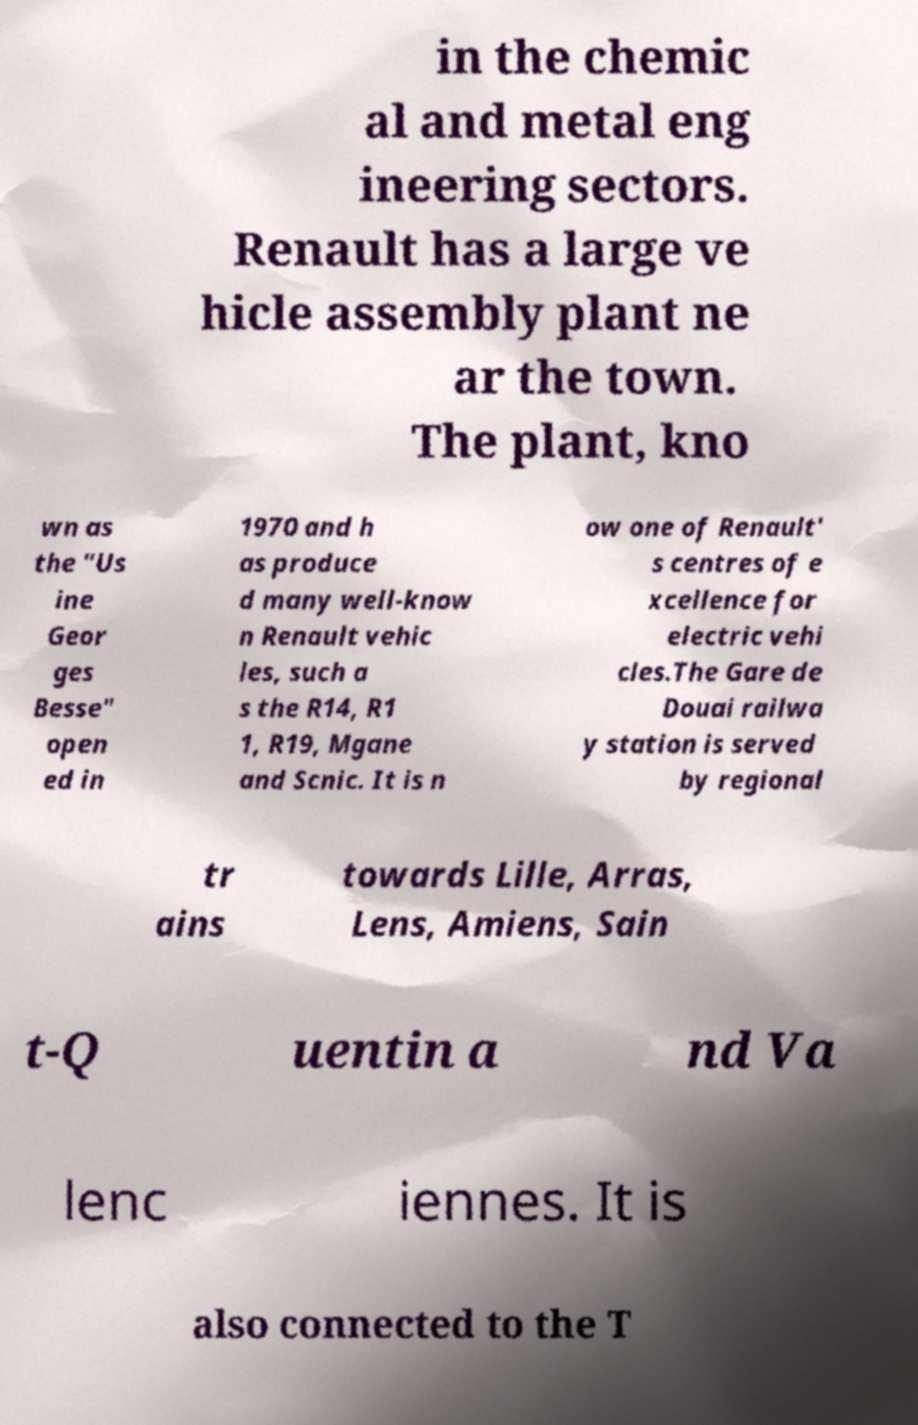For documentation purposes, I need the text within this image transcribed. Could you provide that? in the chemic al and metal eng ineering sectors. Renault has a large ve hicle assembly plant ne ar the town. The plant, kno wn as the "Us ine Geor ges Besse" open ed in 1970 and h as produce d many well-know n Renault vehic les, such a s the R14, R1 1, R19, Mgane and Scnic. It is n ow one of Renault' s centres of e xcellence for electric vehi cles.The Gare de Douai railwa y station is served by regional tr ains towards Lille, Arras, Lens, Amiens, Sain t-Q uentin a nd Va lenc iennes. It is also connected to the T 